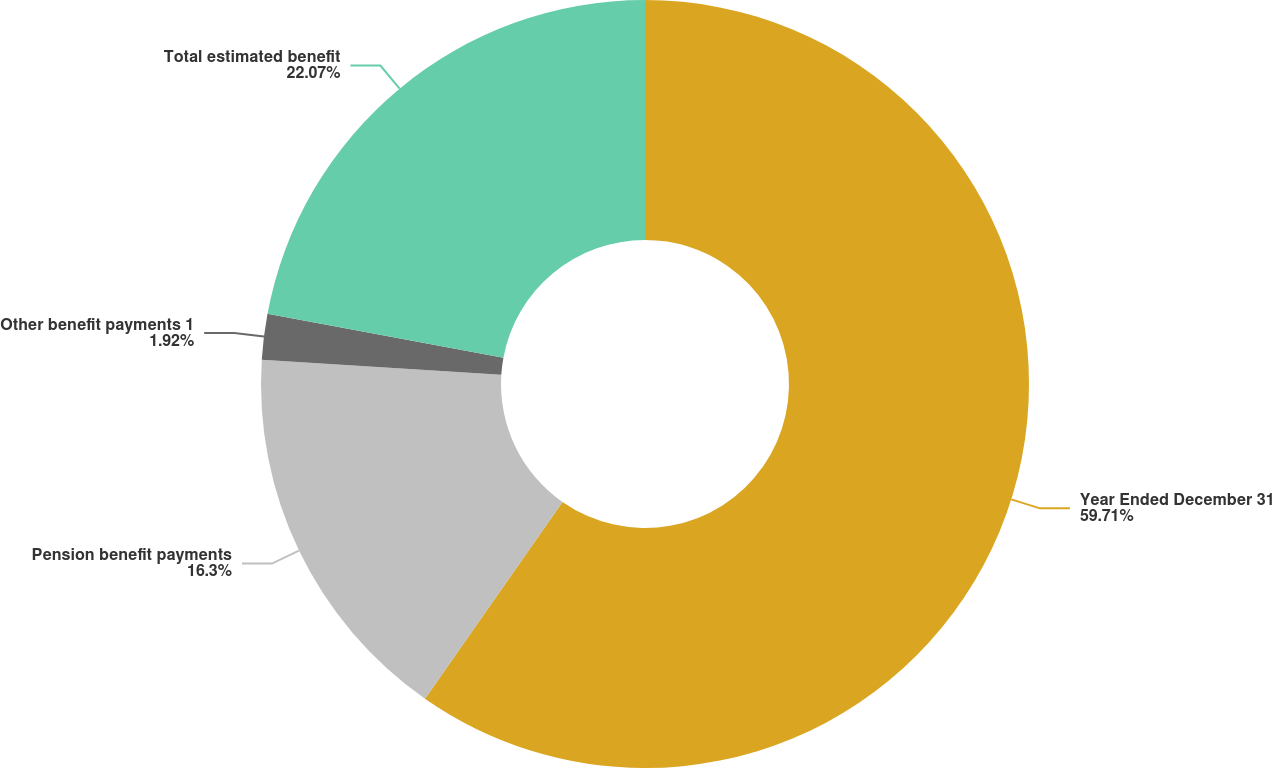Convert chart to OTSL. <chart><loc_0><loc_0><loc_500><loc_500><pie_chart><fcel>Year Ended December 31<fcel>Pension benefit payments<fcel>Other benefit payments 1<fcel>Total estimated benefit<nl><fcel>59.71%<fcel>16.3%<fcel>1.92%<fcel>22.07%<nl></chart> 